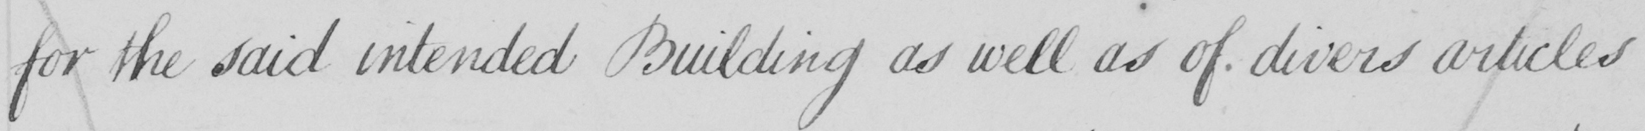What text is written in this handwritten line? for the said intended Building as well as of divers articles 